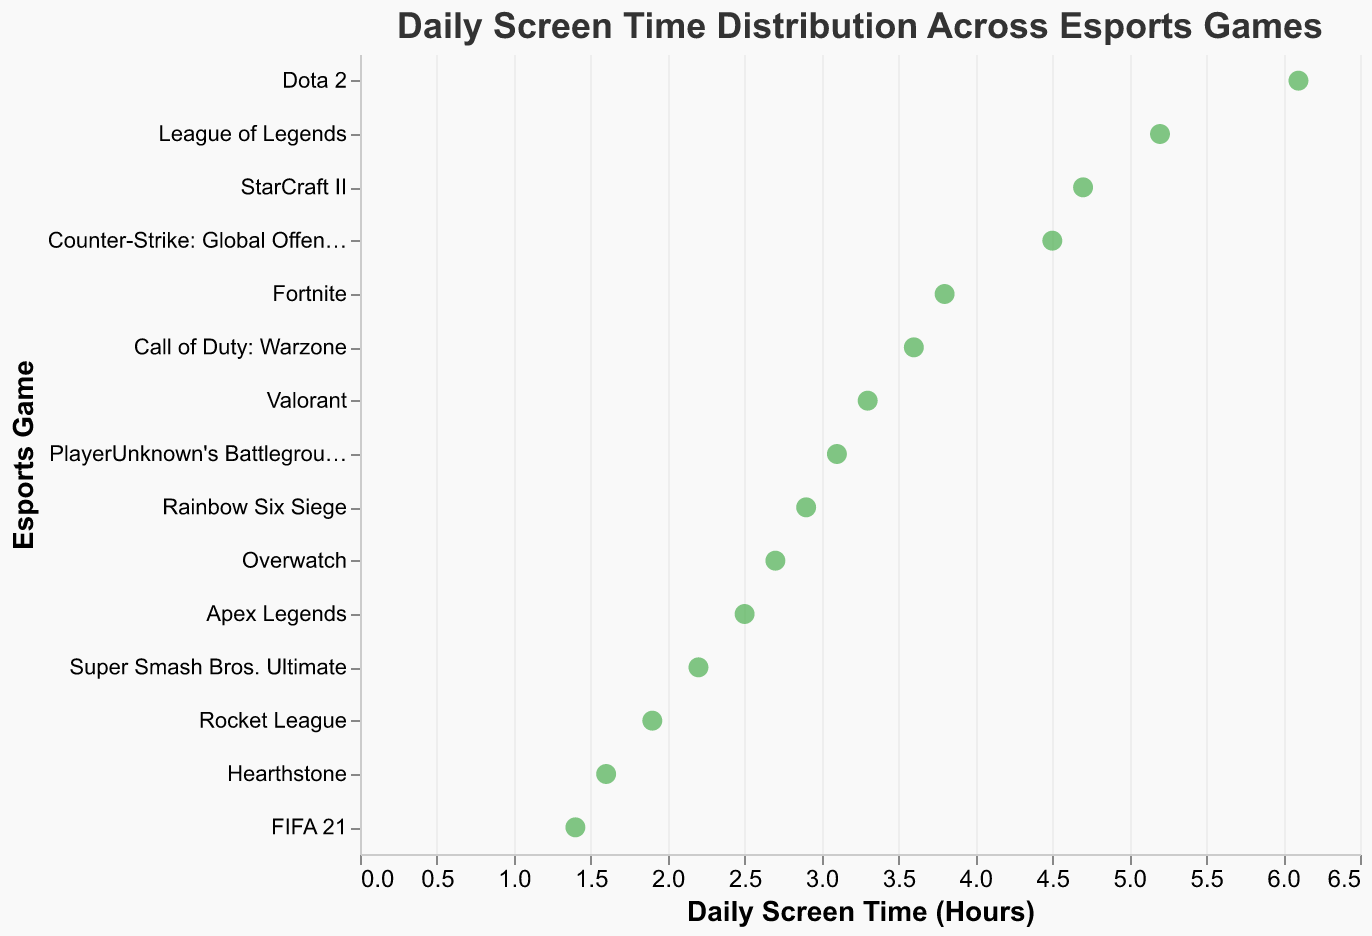What's the title of the figure? The title is clearly stated at the top of the figure as "Daily Screen Time Distribution Across Esports Games".
Answer: Daily Screen Time Distribution Across Esports Games How many data points are there in the plot? Each data point represents an esports game, and there are 15 sports game names listed.
Answer: 15 Which game has the highest daily screen time? By looking at the horizontal positioning of the points, Dota 2 is positioned the furthest to the right, indicating the highest screen time.
Answer: Dota 2 What is the daily screen time for FIFA 21? Locate FIFA 21 on the vertical axis and check the corresponding value on the horizontal axis, which shows 1.4 hours.
Answer: 1.4 hours What is the general range of daily screen time across all games? By observing the horizontal axis, the minimum screen time is about 1.4 hours and the maximum is 6.1 hours.
Answer: 1.4 to 6.1 hours Which game has a daily screen time closest to 3 hours? Look along the horizontal axis for the value closest to 3 hours and find the corresponding game, which is Rainbow Six Siege at 2.9 hours.
Answer: Rainbow Six Siege How much more is the screen time for League of Legends compared to Overwatch? League of Legends has 5.2 hours and Overwatch has 2.7 hours. Subtracting: 5.2 - 2.7 = 2.5 hours more.
Answer: 2.5 hours Which games have daily screen time greater than 4 hours? Identify all points with horizontal values greater than 4, which are League of Legends, Counter-Strike: Global Offensive, Dota 2, and StarCraft II.
Answer: League of Legends, Counter-Strike: Global Offensive, Dota 2, StarCraft II What is the average screen time of Apex Legends and Valorant? Apex Legends has 2.5 hours and Valorant has 3.3 hours. Average: (2.5 + 3.3) / 2 = 2.9 hours.
Answer: 2.9 hours What is the difference in screen time between the game with the highest and the game with the lowest screen time? The highest screen time is for Dota 2 at 6.1 hours and the lowest is for FIFA 21 at 1.4 hours. Difference: 6.1 - 1.4 = 4.7 hours.
Answer: 4.7 hours 